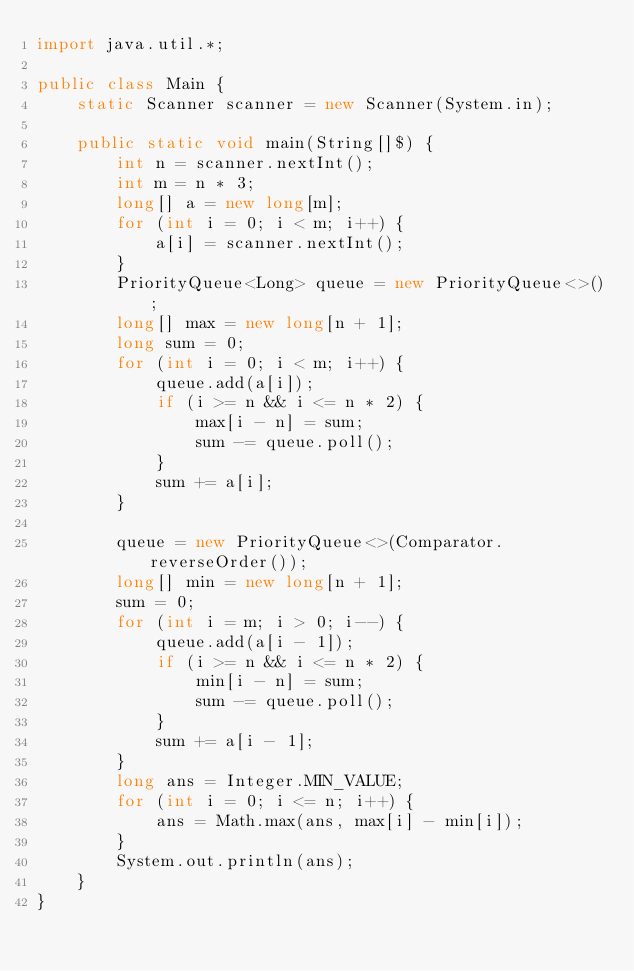Convert code to text. <code><loc_0><loc_0><loc_500><loc_500><_Java_>import java.util.*;
 
public class Main {
    static Scanner scanner = new Scanner(System.in);
 
    public static void main(String[]$) {
        int n = scanner.nextInt();
        int m = n * 3;
        long[] a = new long[m];
        for (int i = 0; i < m; i++) {
            a[i] = scanner.nextInt();
        }
        PriorityQueue<Long> queue = new PriorityQueue<>();
        long[] max = new long[n + 1];
        long sum = 0;
        for (int i = 0; i < m; i++) {
            queue.add(a[i]);
            if (i >= n && i <= n * 2) {
                max[i - n] = sum;
                sum -= queue.poll();
            }
            sum += a[i];
        }
 
        queue = new PriorityQueue<>(Comparator.reverseOrder());
        long[] min = new long[n + 1];
        sum = 0;
        for (int i = m; i > 0; i--) {
            queue.add(a[i - 1]);
            if (i >= n && i <= n * 2) {
                min[i - n] = sum;
                sum -= queue.poll();
            }
            sum += a[i - 1];
        }
        long ans = Integer.MIN_VALUE;
        for (int i = 0; i <= n; i++) {
            ans = Math.max(ans, max[i] - min[i]);
        }
        System.out.println(ans);
    }
}</code> 